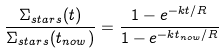Convert formula to latex. <formula><loc_0><loc_0><loc_500><loc_500>\frac { \Sigma _ { s t a r s } ( t ) } { \Sigma _ { s t a r s } ( t _ { n o w } ) } = \frac { 1 - e ^ { - k t / R } } { 1 - e ^ { - k t _ { n o w } / R } }</formula> 